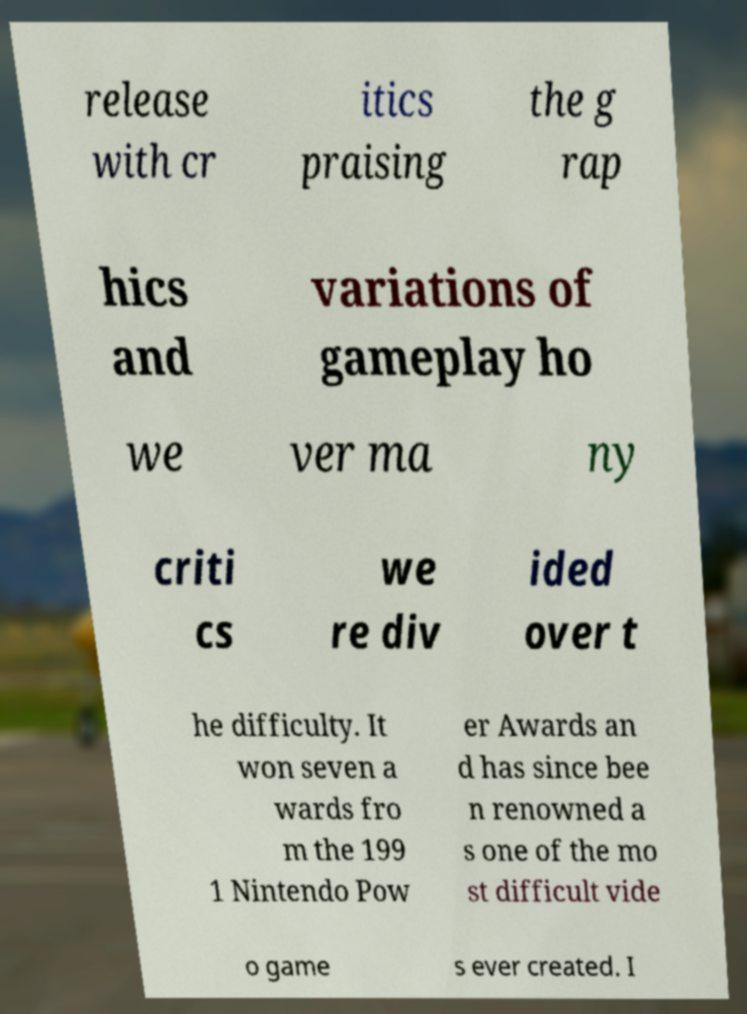Can you accurately transcribe the text from the provided image for me? release with cr itics praising the g rap hics and variations of gameplay ho we ver ma ny criti cs we re div ided over t he difficulty. It won seven a wards fro m the 199 1 Nintendo Pow er Awards an d has since bee n renowned a s one of the mo st difficult vide o game s ever created. I 